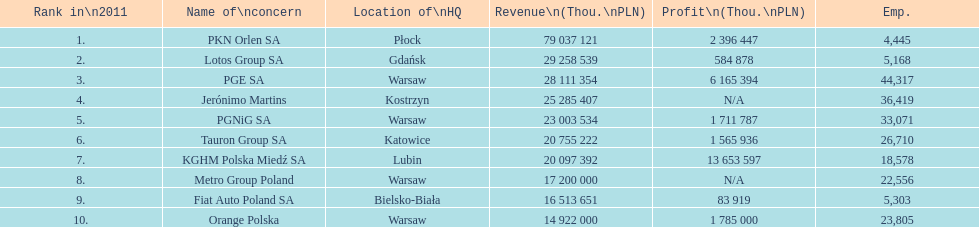Which company had the least revenue? Orange Polska. 